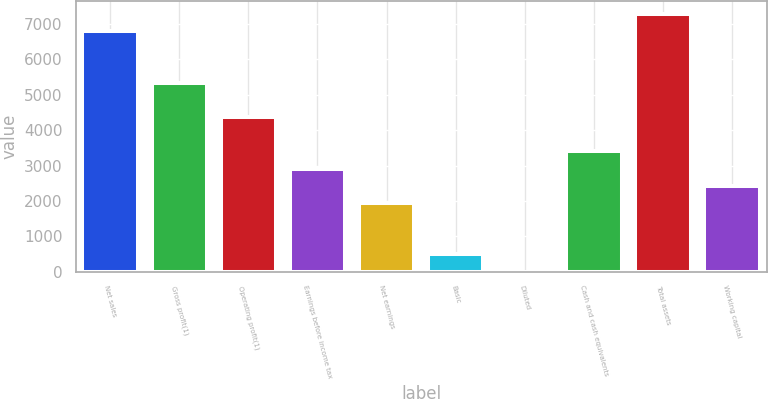<chart> <loc_0><loc_0><loc_500><loc_500><bar_chart><fcel>Net sales<fcel>Gross profit(1)<fcel>Operating profit(1)<fcel>Earnings before income tax<fcel>Net earnings<fcel>Basic<fcel>Diluted<fcel>Cash and cash equivalents<fcel>Total assets<fcel>Working capital<nl><fcel>6796.59<fcel>5340.42<fcel>4369.64<fcel>2913.47<fcel>1942.69<fcel>486.52<fcel>1.13<fcel>3398.86<fcel>7281.98<fcel>2428.08<nl></chart> 